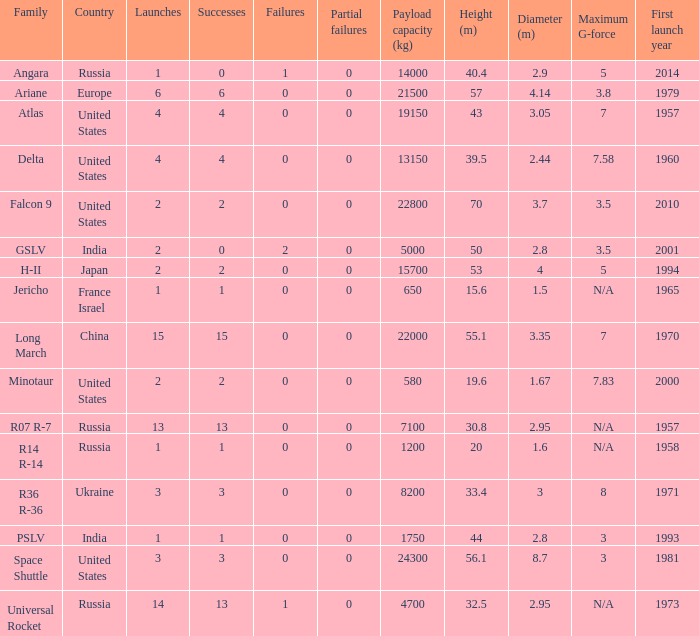Would you be able to parse every entry in this table? {'header': ['Family', 'Country', 'Launches', 'Successes', 'Failures', 'Partial failures', 'Payload capacity (kg)', 'Height (m)', 'Diameter (m)', 'Maximum G-force', 'First launch year'], 'rows': [['Angara', 'Russia', '1', '0', '1', '0', '14000', '40.4', '2.9', '5', '2014'], ['Ariane', 'Europe', '6', '6', '0', '0', '21500', '57', '4.14', '3.8', '1979'], ['Atlas', 'United States', '4', '4', '0', '0', '19150', '43', '3.05', '7', '1957'], ['Delta', 'United States', '4', '4', '0', '0', '13150', '39.5', '2.44', '7.58', '1960'], ['Falcon 9', 'United States', '2', '2', '0', '0', '22800', '70', '3.7', '3.5', '2010'], ['GSLV', 'India', '2', '0', '2', '0', '5000', '50', '2.8', '3.5', '2001'], ['H-II', 'Japan', '2', '2', '0', '0', '15700', '53', '4', '5', '1994'], ['Jericho', 'France Israel', '1', '1', '0', '0', '650', '15.6', '1.5', 'N/A', '1965'], ['Long March', 'China', '15', '15', '0', '0', '22000', '55.1', '3.35', '7', '1970'], ['Minotaur', 'United States', '2', '2', '0', '0', '580', '19.6', '1.67', '7.83', '2000'], ['R07 R-7', 'Russia', '13', '13', '0', '0', '7100', '30.8', '2.95', 'N/A', '1957'], ['R14 R-14', 'Russia', '1', '1', '0', '0', '1200', '20', '1.6', 'N/A', '1958'], ['R36 R-36', 'Ukraine', '3', '3', '0', '0', '8200', '33.4', '3', '8', '1971'], ['PSLV', 'India', '1', '1', '0', '0', '1750', '44', '2.8', '3', '1993'], ['Space Shuttle', 'United States', '3', '3', '0', '0', '24300', '56.1', '8.7', '3', '1981'], ['Universal Rocket', 'Russia', '14', '13', '1', '0', '4700', '32.5', '2.95', 'N/A', '1973']]} What is the partial failure for the Country of russia, and a Failure larger than 0, and a Family of angara, and a Launch larger than 1? None. 